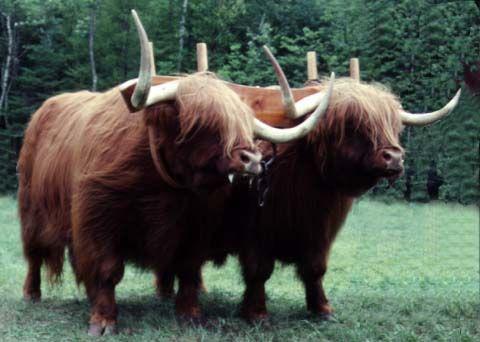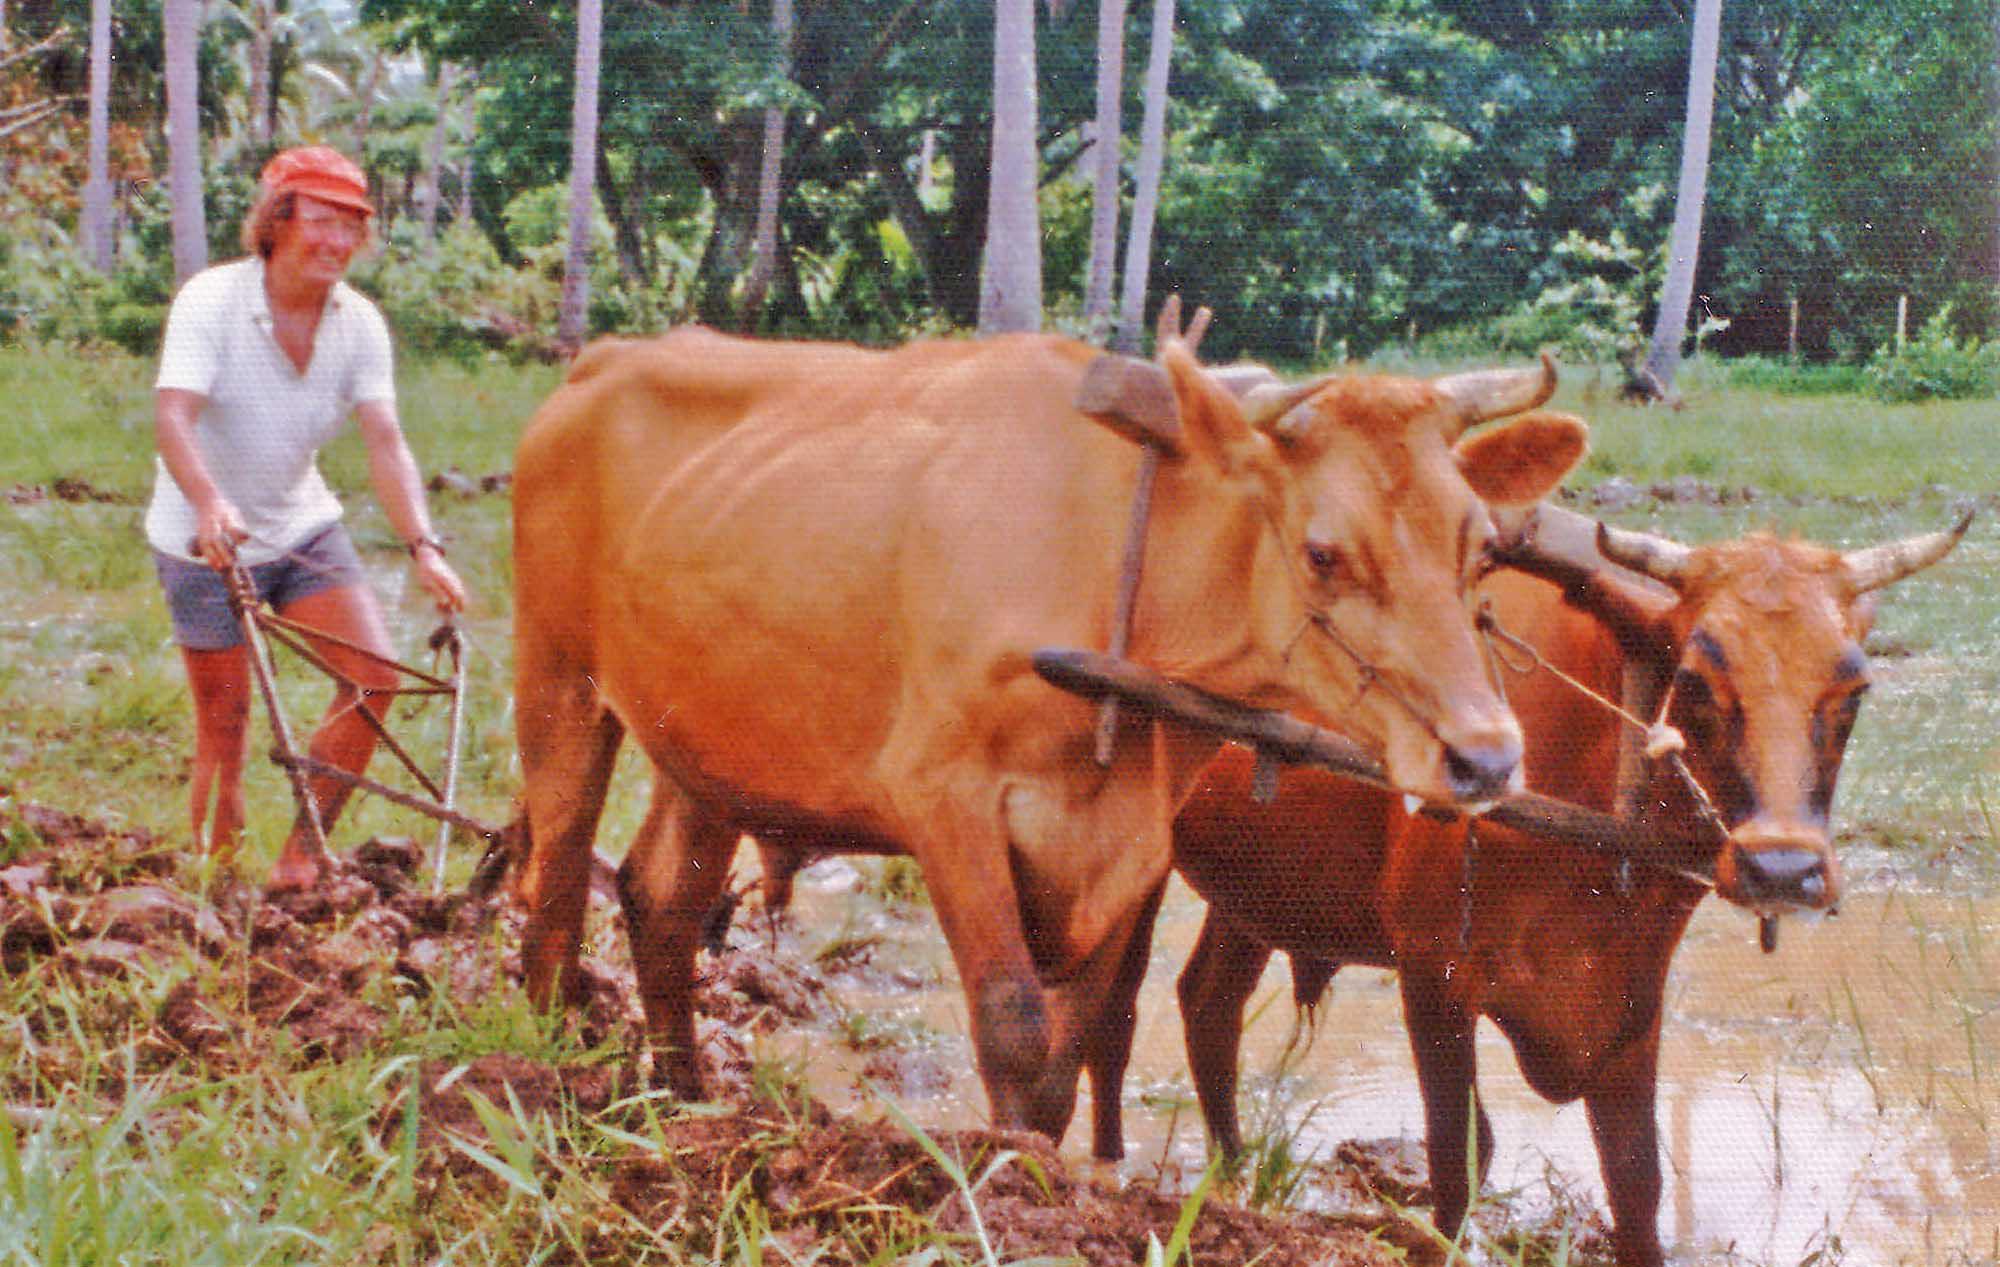The first image is the image on the left, the second image is the image on the right. Assess this claim about the two images: "Both images show cows plowing a field.". Correct or not? Answer yes or no. No. The first image is the image on the left, the second image is the image on the right. Analyze the images presented: Is the assertion "One image shows two brown cattle wearing a wooden plow hitch and angled rightward, and the other image shows a person standing behind a team of two cattle." valid? Answer yes or no. Yes. 